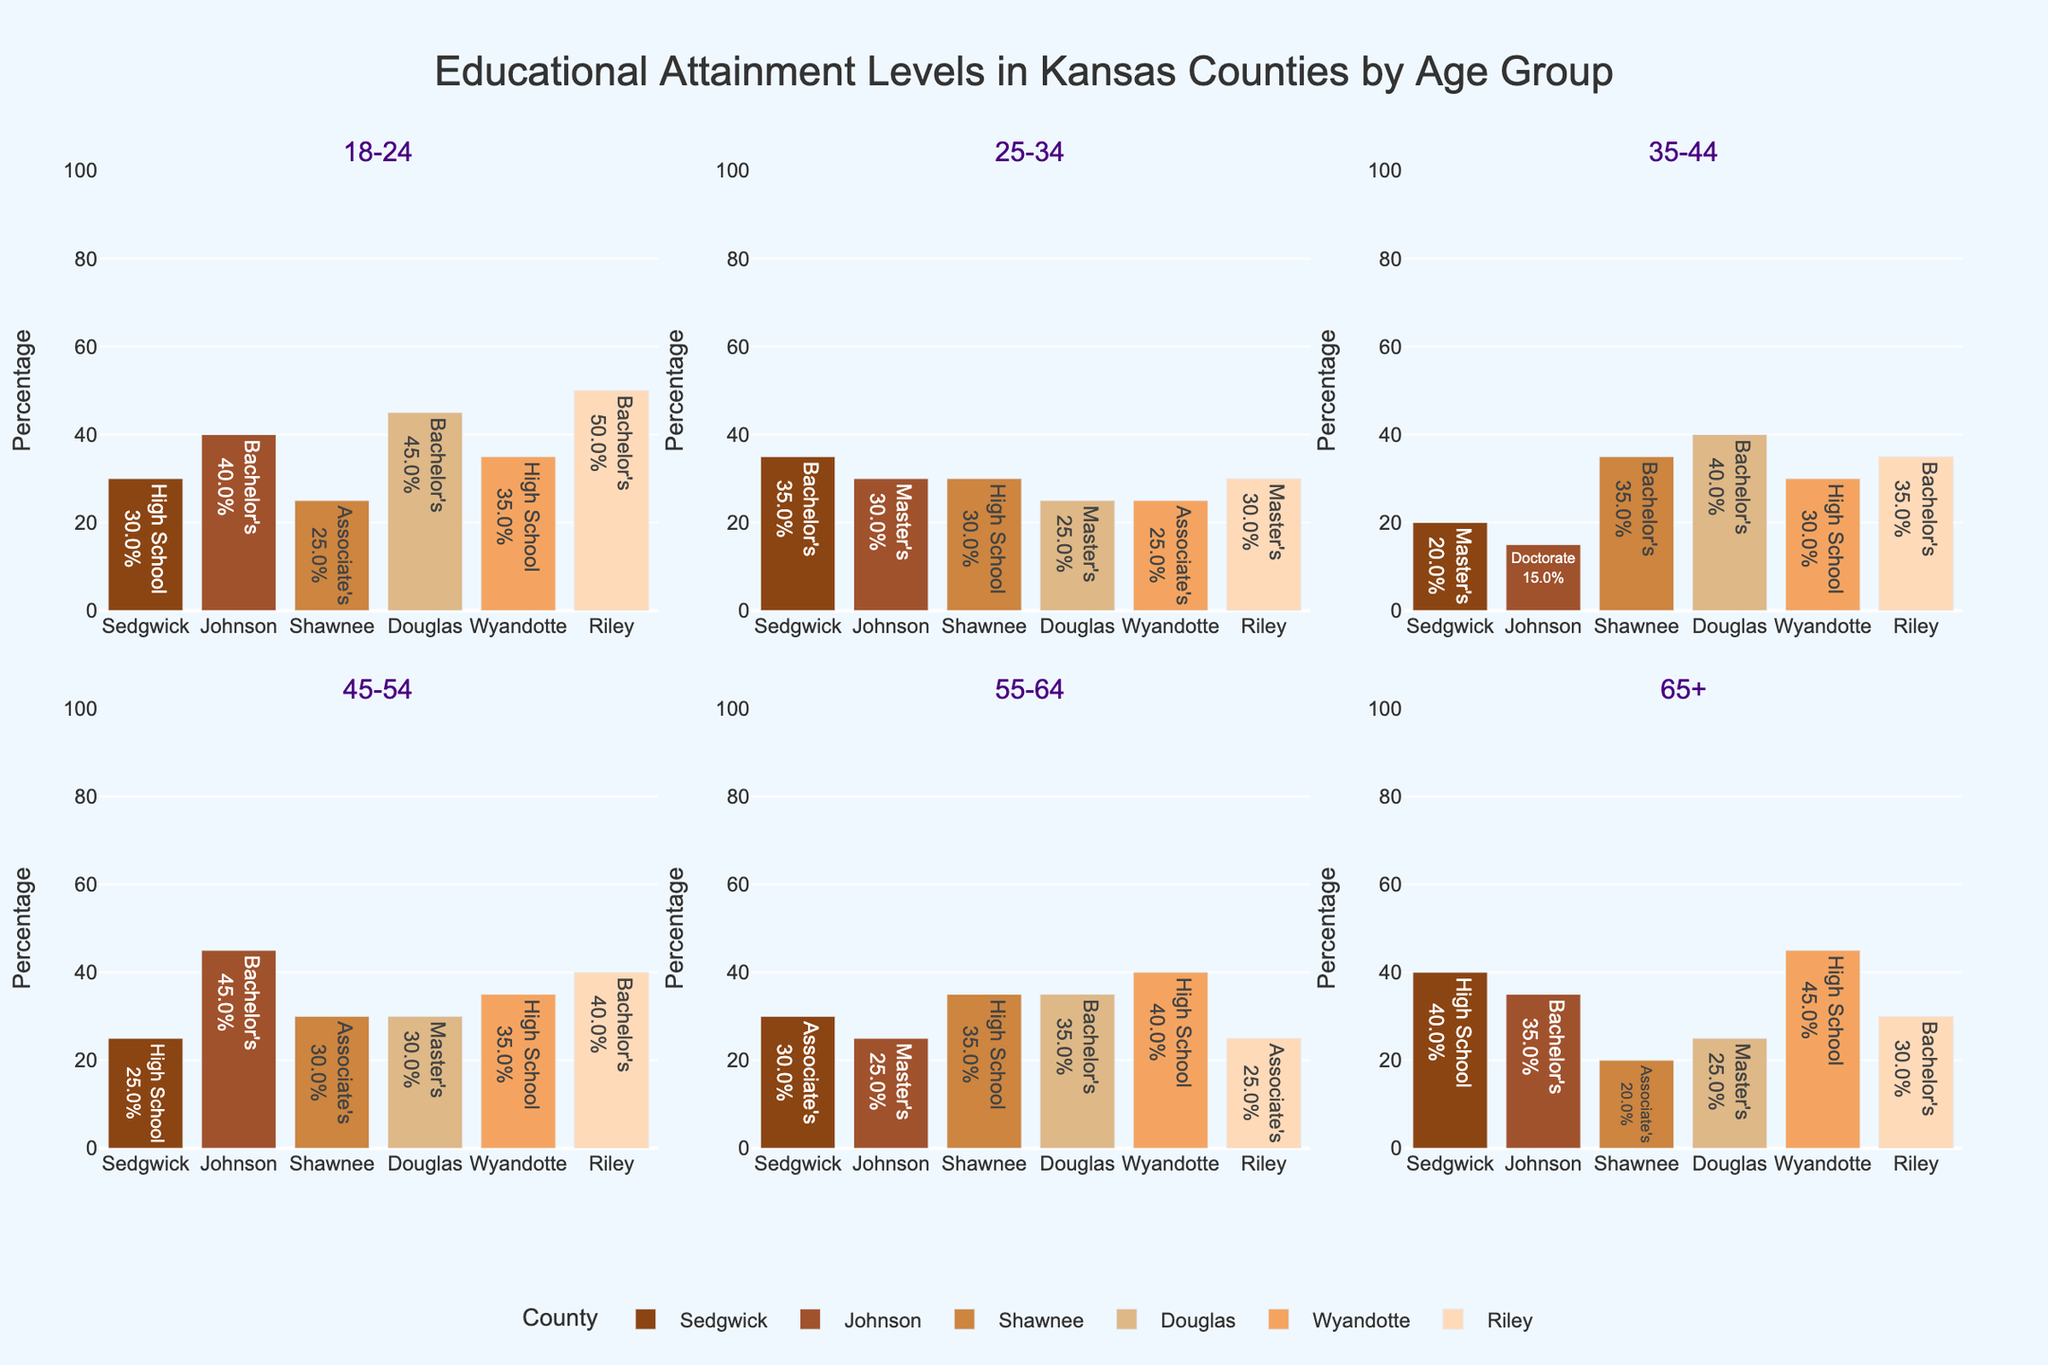What is the percentage of Bachelor's degree holders in the 25-34 age group in Johnson County? Look at the subplot for the 25-34 age group and locate the bar for Johnson County. The text indicates "Master's: 30%" as the highest level of attainment.
Answer: 40% Which county has the highest percentage of Bachelor's degree holders in the 18-24 age group? Look at the subplot for the 18-24 age group and compare the heights of the bars indicating Bachelor's degree holders. Riley County has the highest percentage (50%).
Answer: Riley What is the difference in the percentage of Master’s degree holders between the 25-34 and 45-54 age groups in Douglas County? Look at the subplots for 25-34 and 45-54 age groups. Douglas County’s bars show 25% for 25-34 and 30% for 45-54. The difference is 30% - 25%.
Answer: 5% How many counties have a Bachelor's degree as the highest level of educational attainment in the 55-64 age group? In the 55-64 age group subplot, count the number of bars where Bachelor's degree percentages are the highest. Douglas and Johnson counties represent this category.
Answer: 2 In which age group does Wyandotte County have the highest percentage of High School graduates? Inspect each subplot for all age groups. Wyandotte County shows the highest bar for High School graduates in the 65+ age group at 45%.
Answer: 65+ What is the average percentage of High School graduates in the 18-24 age group across all counties? Look at the 18-24 age group subplot and note the High School percentages for each county. Sum them (30% for Sedgwick, 35% for Wyandotte) and divide by the number of counties. The average is (30 + 35) / 2.
Answer: 32.5% Compare the highest education levels in the 35-44 and 55-64 age groups in Sedgwick County. Are they the same or different? Look at the 35-44 and 55-64 age group subplots. Sedgwick County shows Bachelor's level highest in 35-44 and Associate's level highest in 55-64.
Answer: Different Which county shows the lowest percentage of educational attainment for any given age group? Examine all subplots for each age group to find the lowest single percentage. Shawnee County in the 65+ age group shows the lowest percentage, Associate's: 20%.
Answer: Shawnee What is the total percentage of Bachelor’s degree holders across all age groups in Riley County? Sum the percentages of Bachelor's degree holders for all age groups in Riley County. Percentages are 50%, 35%, 40%, 30%, and 30%. The sum is 50 + 35 + 40 + 30 + 30.
Answer: 185% Does any county have a consistent level of educational attainment (same percentage) across all age groups? Compare the education attainment levels for each county across all age groups. None of the counties maintain a consistent level across all age groups.
Answer: No 